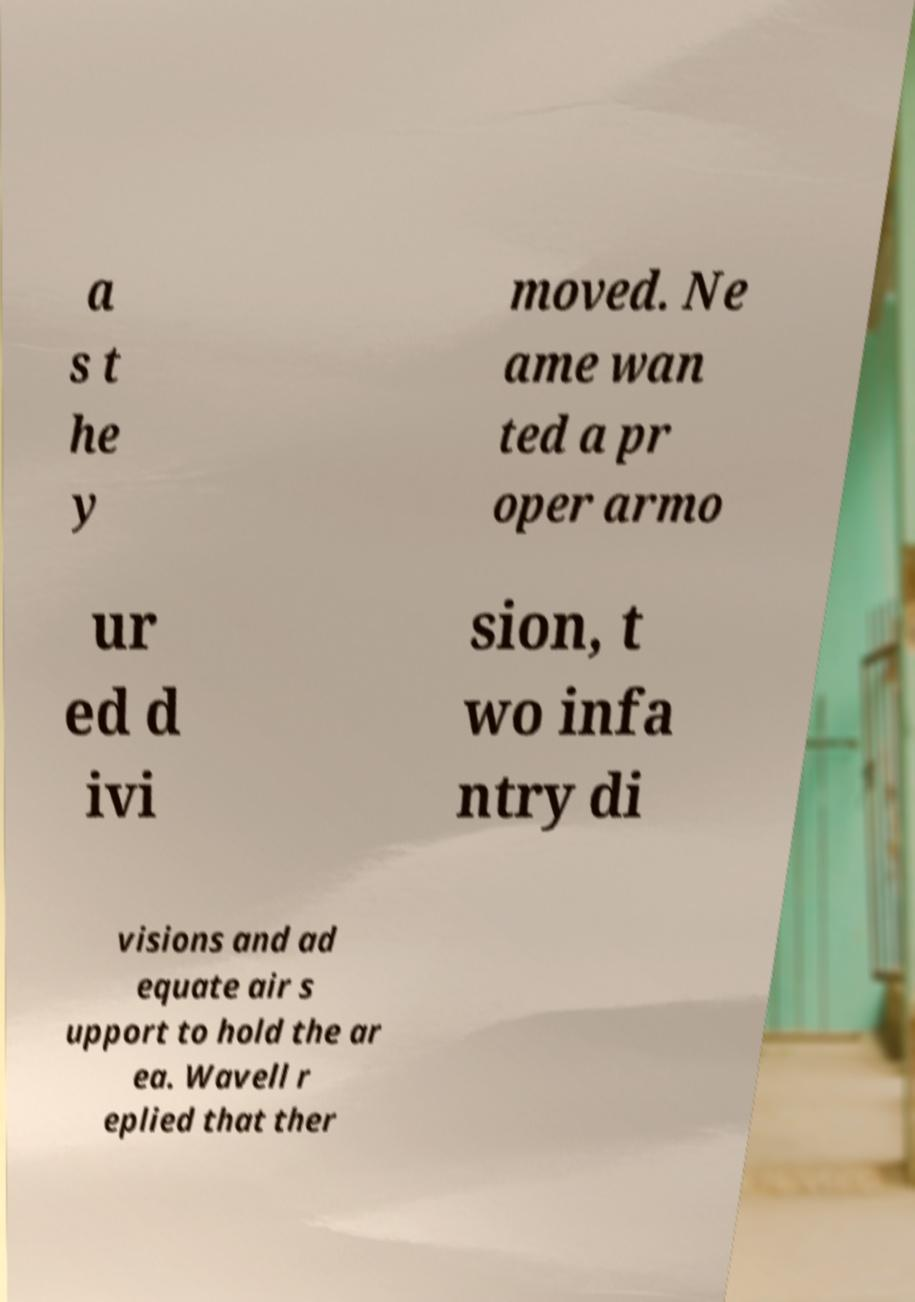Please identify and transcribe the text found in this image. a s t he y moved. Ne ame wan ted a pr oper armo ur ed d ivi sion, t wo infa ntry di visions and ad equate air s upport to hold the ar ea. Wavell r eplied that ther 